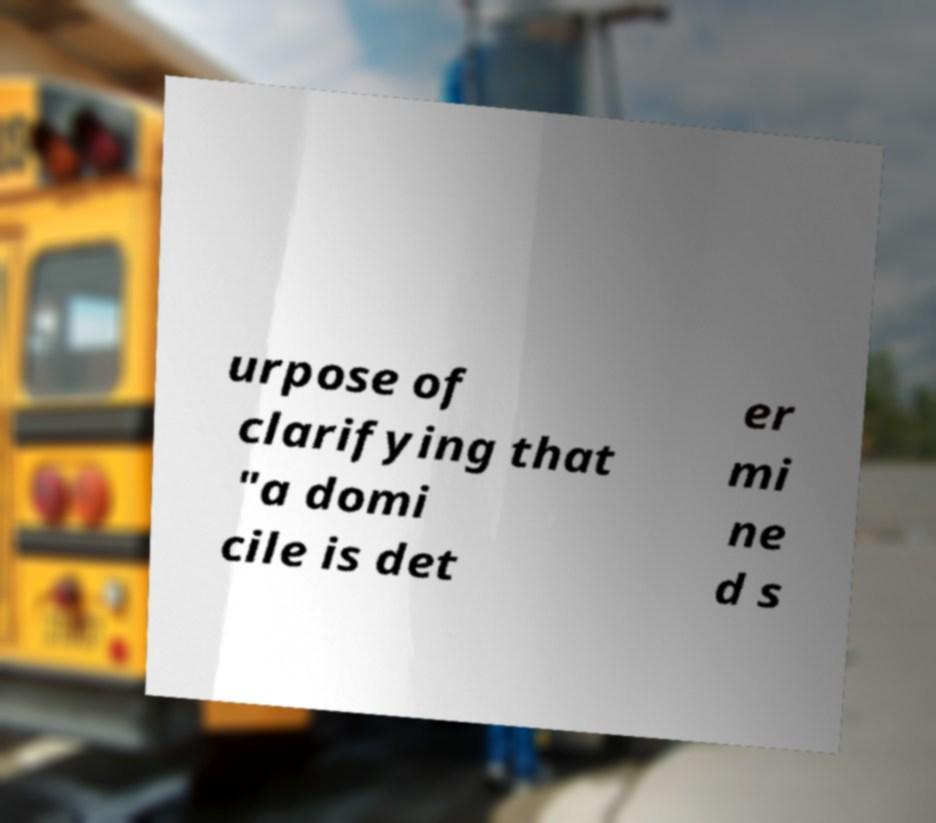Please identify and transcribe the text found in this image. urpose of clarifying that "a domi cile is det er mi ne d s 